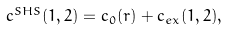<formula> <loc_0><loc_0><loc_500><loc_500>\text {\ } c ^ { S H S } ( 1 , 2 ) = c _ { 0 } ( r ) + c _ { e x } ( 1 , 2 ) ,</formula> 